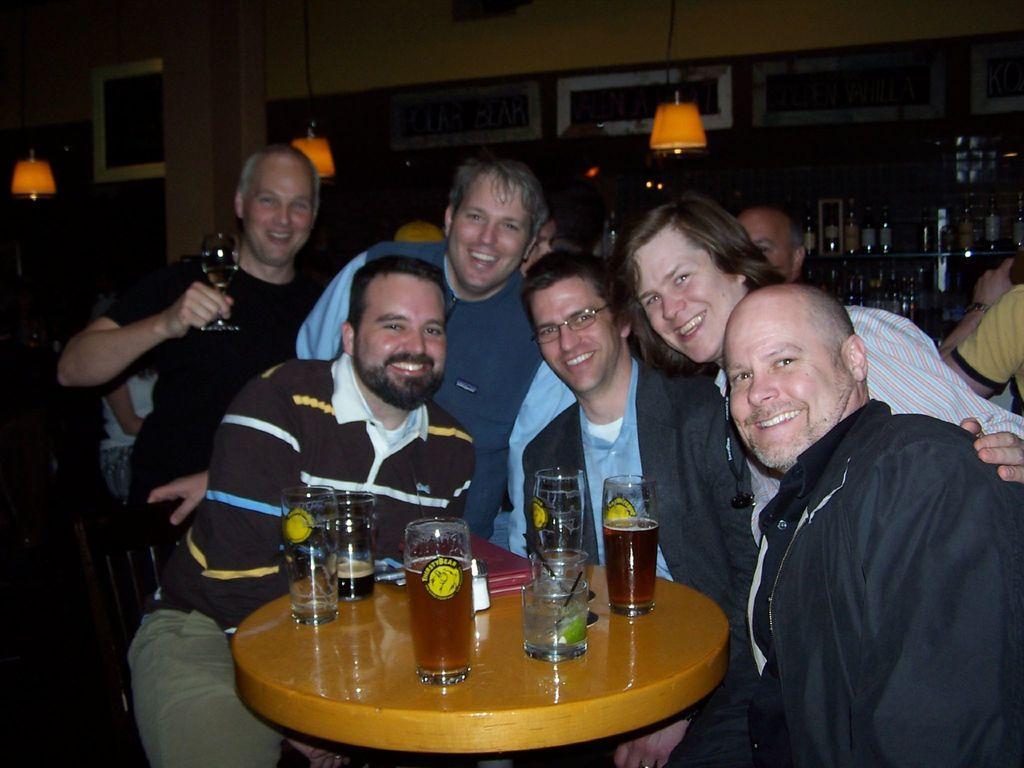Can you describe this image briefly? In this image we can see few people are near the table and each of them are smiling. There is the table upon which glasses with drinks are placed. In the background we can see few bottles and lamps. 